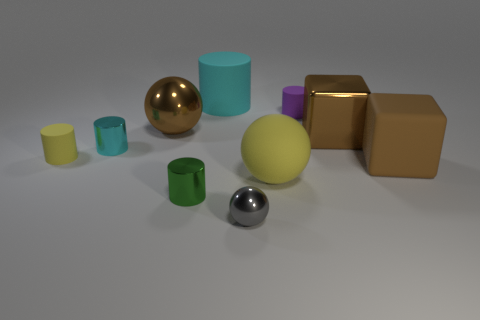Is there anything else that has the same size as the brown ball?
Your answer should be very brief. Yes. The small matte cylinder in front of the cyan shiny thing that is in front of the shiny ball that is behind the small gray thing is what color?
Your answer should be very brief. Yellow. Does the tiny ball have the same material as the large ball left of the big yellow ball?
Ensure brevity in your answer.  Yes. What material is the yellow cylinder?
Your answer should be compact. Rubber. There is a cylinder that is the same color as the big matte ball; what is it made of?
Offer a very short reply. Rubber. How many other things are made of the same material as the small green cylinder?
Your response must be concise. 4. There is a matte object that is right of the tiny cyan metallic cylinder and left of the large rubber sphere; what shape is it?
Ensure brevity in your answer.  Cylinder. There is another small object that is made of the same material as the small yellow object; what is its color?
Offer a very short reply. Purple. Is the number of things right of the brown matte object the same as the number of small purple rubber objects?
Offer a terse response. No. What shape is the purple matte object that is the same size as the green shiny thing?
Offer a very short reply. Cylinder. 